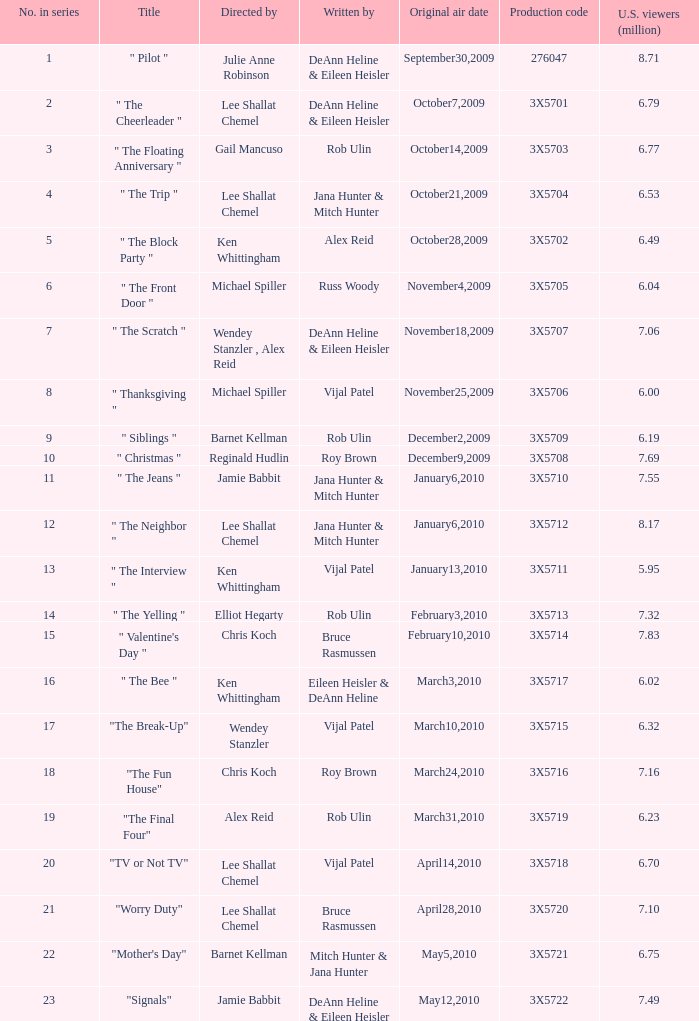How many million U.S. viewers saw the episode with production code 3X5710? 7.55. 